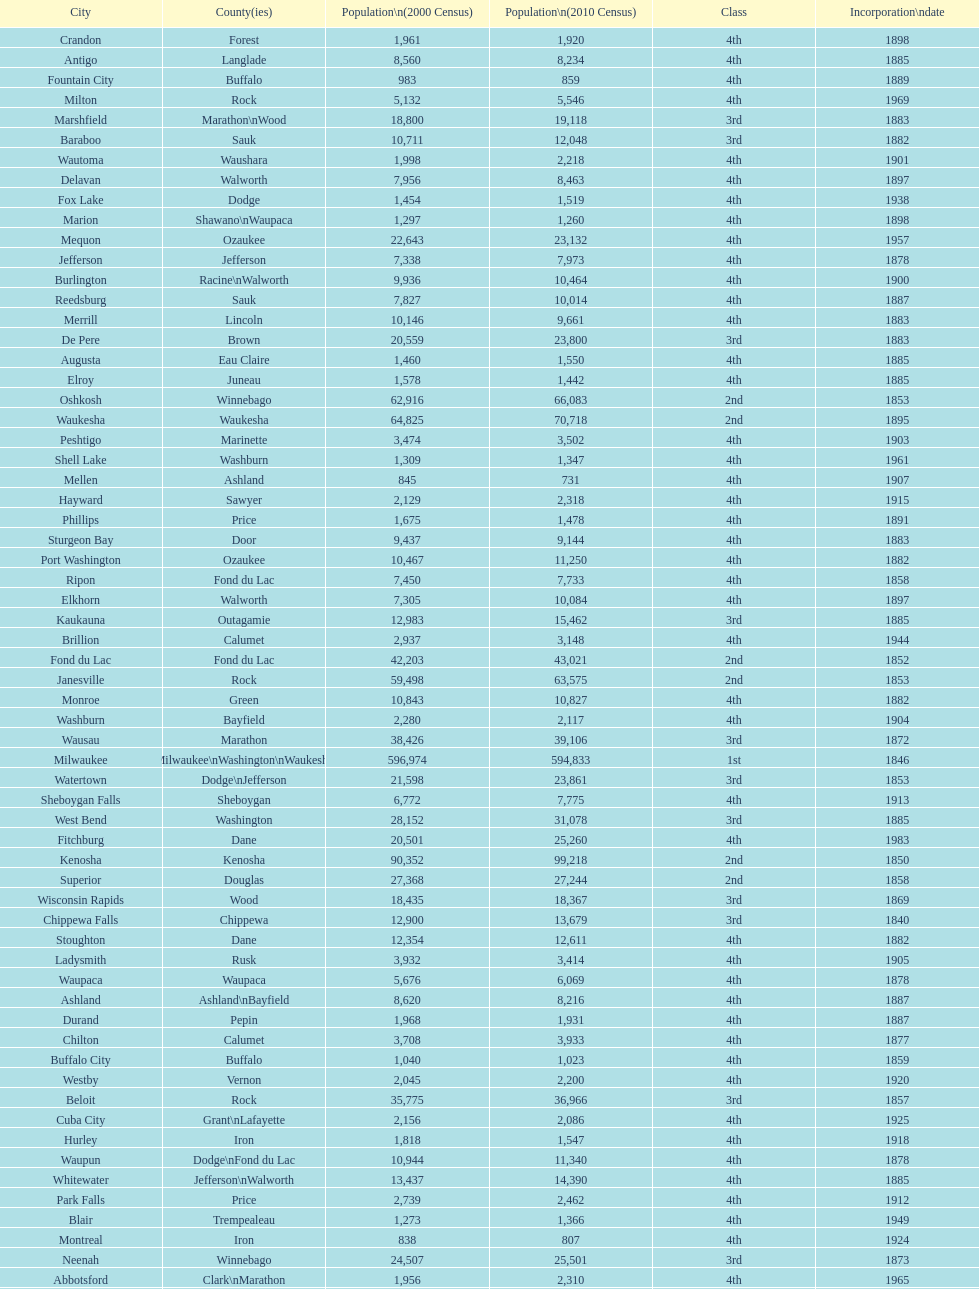Which city has the most population in the 2010 census? Milwaukee. Help me parse the entirety of this table. {'header': ['City', 'County(ies)', 'Population\\n(2000 Census)', 'Population\\n(2010 Census)', 'Class', 'Incorporation\\ndate'], 'rows': [['Crandon', 'Forest', '1,961', '1,920', '4th', '1898'], ['Antigo', 'Langlade', '8,560', '8,234', '4th', '1885'], ['Fountain City', 'Buffalo', '983', '859', '4th', '1889'], ['Milton', 'Rock', '5,132', '5,546', '4th', '1969'], ['Marshfield', 'Marathon\\nWood', '18,800', '19,118', '3rd', '1883'], ['Baraboo', 'Sauk', '10,711', '12,048', '3rd', '1882'], ['Wautoma', 'Waushara', '1,998', '2,218', '4th', '1901'], ['Delavan', 'Walworth', '7,956', '8,463', '4th', '1897'], ['Fox Lake', 'Dodge', '1,454', '1,519', '4th', '1938'], ['Marion', 'Shawano\\nWaupaca', '1,297', '1,260', '4th', '1898'], ['Mequon', 'Ozaukee', '22,643', '23,132', '4th', '1957'], ['Jefferson', 'Jefferson', '7,338', '7,973', '4th', '1878'], ['Burlington', 'Racine\\nWalworth', '9,936', '10,464', '4th', '1900'], ['Reedsburg', 'Sauk', '7,827', '10,014', '4th', '1887'], ['Merrill', 'Lincoln', '10,146', '9,661', '4th', '1883'], ['De Pere', 'Brown', '20,559', '23,800', '3rd', '1883'], ['Augusta', 'Eau Claire', '1,460', '1,550', '4th', '1885'], ['Elroy', 'Juneau', '1,578', '1,442', '4th', '1885'], ['Oshkosh', 'Winnebago', '62,916', '66,083', '2nd', '1853'], ['Waukesha', 'Waukesha', '64,825', '70,718', '2nd', '1895'], ['Peshtigo', 'Marinette', '3,474', '3,502', '4th', '1903'], ['Shell Lake', 'Washburn', '1,309', '1,347', '4th', '1961'], ['Mellen', 'Ashland', '845', '731', '4th', '1907'], ['Hayward', 'Sawyer', '2,129', '2,318', '4th', '1915'], ['Phillips', 'Price', '1,675', '1,478', '4th', '1891'], ['Sturgeon Bay', 'Door', '9,437', '9,144', '4th', '1883'], ['Port Washington', 'Ozaukee', '10,467', '11,250', '4th', '1882'], ['Ripon', 'Fond du Lac', '7,450', '7,733', '4th', '1858'], ['Elkhorn', 'Walworth', '7,305', '10,084', '4th', '1897'], ['Kaukauna', 'Outagamie', '12,983', '15,462', '3rd', '1885'], ['Brillion', 'Calumet', '2,937', '3,148', '4th', '1944'], ['Fond du Lac', 'Fond du Lac', '42,203', '43,021', '2nd', '1852'], ['Janesville', 'Rock', '59,498', '63,575', '2nd', '1853'], ['Monroe', 'Green', '10,843', '10,827', '4th', '1882'], ['Washburn', 'Bayfield', '2,280', '2,117', '4th', '1904'], ['Wausau', 'Marathon', '38,426', '39,106', '3rd', '1872'], ['Milwaukee', 'Milwaukee\\nWashington\\nWaukesha', '596,974', '594,833', '1st', '1846'], ['Watertown', 'Dodge\\nJefferson', '21,598', '23,861', '3rd', '1853'], ['Sheboygan Falls', 'Sheboygan', '6,772', '7,775', '4th', '1913'], ['West Bend', 'Washington', '28,152', '31,078', '3rd', '1885'], ['Fitchburg', 'Dane', '20,501', '25,260', '4th', '1983'], ['Kenosha', 'Kenosha', '90,352', '99,218', '2nd', '1850'], ['Superior', 'Douglas', '27,368', '27,244', '2nd', '1858'], ['Wisconsin Rapids', 'Wood', '18,435', '18,367', '3rd', '1869'], ['Chippewa Falls', 'Chippewa', '12,900', '13,679', '3rd', '1840'], ['Stoughton', 'Dane', '12,354', '12,611', '4th', '1882'], ['Ladysmith', 'Rusk', '3,932', '3,414', '4th', '1905'], ['Waupaca', 'Waupaca', '5,676', '6,069', '4th', '1878'], ['Ashland', 'Ashland\\nBayfield', '8,620', '8,216', '4th', '1887'], ['Durand', 'Pepin', '1,968', '1,931', '4th', '1887'], ['Chilton', 'Calumet', '3,708', '3,933', '4th', '1877'], ['Buffalo City', 'Buffalo', '1,040', '1,023', '4th', '1859'], ['Westby', 'Vernon', '2,045', '2,200', '4th', '1920'], ['Beloit', 'Rock', '35,775', '36,966', '3rd', '1857'], ['Cuba City', 'Grant\\nLafayette', '2,156', '2,086', '4th', '1925'], ['Hurley', 'Iron', '1,818', '1,547', '4th', '1918'], ['Waupun', 'Dodge\\nFond du Lac', '10,944', '11,340', '4th', '1878'], ['Whitewater', 'Jefferson\\nWalworth', '13,437', '14,390', '4th', '1885'], ['Park Falls', 'Price', '2,739', '2,462', '4th', '1912'], ['Blair', 'Trempealeau', '1,273', '1,366', '4th', '1949'], ['Montreal', 'Iron', '838', '807', '4th', '1924'], ['Neenah', 'Winnebago', '24,507', '25,501', '3rd', '1873'], ['Abbotsford', 'Clark\\nMarathon', '1,956', '2,310', '4th', '1965'], ['Juneau', 'Dodge', '2,485', '2,814', '4th', '1887'], ['Chetek', 'Barron', '2,180', '2,221', '4th', '1891'], ['Barron', 'Barron', '3,248', '3,423', '4th', '1887'], ['Mayville', 'Dodge', '4,902', '5,154', '4th', '1885'], ['Seymour', 'Outagamie', '3,335', '3,451', '4th', '1879'], ['Portage', 'Columbia', '9,728', '10,324', '4th', '1854'], ['Schofield', 'Marathon', '2,117', '2,169', '4th', '1951'], ['Hillsboro', 'Vernon', '1,302', '1,417', '4th', '1885'], ['Sheboygan', 'Sheboygan', '50,792', '49,288', '2nd', '1853'], ['Montello', 'Marquette', '1,397', '1,495', '4th', '1938'], ['Hudson', 'St. Croix', '8,775', '12,719', '4th', '1858'], ['Colby', 'Clark\\nMarathon', '1,616', '1,852', '4th', '1891'], ['Tomahawk', 'Lincoln', '3,770', '3,397', '4th', '1891'], ['Eau Claire', 'Chippewa\\nEau Claire', '61,704', '65,883', '2nd', '1872'], ['Clintonville', 'Waupaca', '4,736', '4,559', '4th', '1887'], ['Greenfield', 'Milwaukee', '35,476', '36,720', '3rd', '1957'], ['Greenwood', 'Clark', '1,079', '1,026', '4th', '1891'], ['Beaver Dam', 'Dodge', '15,169', '16,243', '4th', '1856'], ['Tomah', 'Monroe', '8,419', '9,093', '4th', '1883'], ['Viroqua', 'Vernon', '4,335', '5,079', '4th', '1885'], ['Nekoosa', 'Wood', '2,590', '2,580', '4th', '1926'], ['Galesville', 'Trempealeau', '1,427', '1,481', '4th', '1942'], ['Franklin', 'Milwaukee', '29,494', '35,451', '3rd', '1956'], ['Shullsburg', 'Lafayette', '1,246', '1,226', '4th', '1889'], ['Green Lake', 'Green Lake', '1,100', '960', '4th', '1962'], ['Bloomer', 'Chippewa', '3,347', '3,539', '4th', '1920'], ['Rhinelander', 'Oneida', '7,735', '7,798', '4th', '1894'], ['Muskego', 'Waukesha', '21,397', '24,135', '3rd', '1964'], ['Brodhead', 'Green\\nRock', '3,180', '3,293', '4th', '1891'], ['New Holstein', 'Calumet', '3,301', '3,236', '4th', '1889'], ['Kiel', 'Calumet\\nManitowoc', '3,450', '3,738', '4th', '1920'], ['New London', 'Outagamie\\nWaupaca', '7,085', '7,295', '4th', '1877'], ['Berlin', 'Green Lake\\nWaushara', '5,305', '5,524', '4th', '1857'], ['Glendale', 'Milwaukee', '13,367', '12,872', '3rd', '1950'], ['Cudahy', 'Milwaukee', '18,429', '18,267', '3rd', '1906'], ['Racine', 'Racine', '81,855', '78,860', '2nd', '1848'], ['Monona', 'Dane', '8,018', '7,533', '4th', '1969'], ['Lake Geneva', 'Walworth', '7,148', '7,651', '4th', '1883'], ['Madison', 'Dane', '208,054', '233,209', '2nd', '1856'], ['St. Francis', 'Milwaukee', '8,662', '9,365', '4th', '1951'], ['West Allis', 'Milwaukee', '61,254', '60,411', '2nd', '1906'], ['Niagara', 'Marinette', '1,880', '1,624', '4th', '1992'], ['Eagle River', 'Vilas', '1,443', '1,398', '4th', '1937'], ['Owen', 'Clark', '936', '940', '4th', '1925'], ['Osseo', 'Trempealeau', '1,669', '1,701', '4th', '1941'], ['South Milwaukee', 'Milwaukee', '21,256', '21,156', '4th', '1897'], ['Rice Lake', 'Barron', '8,312', '8,438', '4th', '1887'], ['Stevens Point', 'Portage', '24,551', '26,717', '3rd', '1858'], ['Horicon', 'Dodge', '3,775', '3,655', '4th', '1897'], ['Stanley', 'Chippewa\\nClark', '1,898', '3,608', '4th', '1898'], ['La Crosse', 'La Crosse', '51,818', '51,320', '2nd', '1856'], ['Oconto', 'Oconto', '4,708', '4,513', '4th', '1869'], ['Richland Center', 'Richland', '5,114', '5,184', '4th', '1887'], ['Arcadia', 'Trempealeau', '2,402', '2,925', '4th', '1925'], ['Appleton', 'Calumet\\nOutagamie\\nWinnebago', '70,087', '72,623', '2nd', '1857'], ['Mosinee', 'Marathon', '4,063', '3,988', '4th', '1931'], ['Gillett', 'Oconto', '1,262', '1,386', '4th', '1944'], ['Edgerton', 'Dane\\nRock', '4,898', '5,461', '4th', '1883'], ['Delafield', 'Waukesha', '6,472', '7,085', '4th', '1959'], ['Kewaunee', 'Kewaunee', '2,806', '2,952', '4th', '1883'], ['Prairie du Chien', 'Crawford', '6,018', '5,911', '4th', '1872'], ['Weyauwega', 'Waupaca', '1,806', '1,900', '4th', '1939'], ['Oconomowoc', 'Waukesha', '12,382', '15,712', '3rd', '1875'], ['New Lisbon', 'Juneau', '1,436', '2,554', '4th', '1889'], ['Lancaster', 'Grant', '4,070', '3,868', '4th', '1878'], ['Hartford', 'Dodge\\nWashington', '10,905', '14,223', '3rd', '1883'], ['Middleton', 'Dane', '15,770', '17,442', '3rd', '1963'], ['Platteville', 'Grant', '9,989', '11,224', '4th', '1876'], ['Shawano', 'Shawano', '8,298', '9,305', '4th', '1874'], ['Wauwatosa', 'Milwaukee', '47,271', '46,396', '2nd', '1897'], ['New Berlin', 'Waukesha', '38,220', '39,584', '3rd', '1959'], ['Plymouth', 'Sheboygan', '7,781', '8,445', '4th', '1877'], ['Dodgeville', 'Iowa', '4,220', '4,698', '4th', '1889'], ['Independence', 'Trempealeau', '1,244', '1,336', '4th', '1942'], ['Lake Mills', 'Jefferson', '4,843', '5,708', '4th', '1905'], ['Evansville', 'Rock', '4,039', '5,012', '4th', '1896'], ['Thorp', 'Clark', '1,536', '1,621', '4th', '1948'], ['Manitowoc', 'Manitowoc', '34,053', '33,736', '3rd', '1870'], ['Fennimore', 'Grant', '2,387', '2,497', '4th', '1919'], ['Oconto Falls', 'Oconto', '2,843', '2,891', '4th', '1919'], ['Princeton', 'Green Lake', '1,504', '1,214', '4th', '1920'], ['Cornell', 'Chippewa', '1,466', '1,467', '4th', '1956'], ['Algoma', 'Kewaunee', '3,357', '3,167', '4th', '1879'], ['Verona', 'Dane', '7,052', '10,619', '4th', '1977'], ['Loyal', 'Clark', '1,308', '1,261', '4th', '1948'], ['Neillsville', 'Clark', '2,731', '2,463', '4th', '1882'], ['Lodi', 'Columbia', '2,882', '3,050', '4th', '1941'], ['Glenwood City', 'St. Croix', '1,183', '1,242', '4th', '1895'], ['Black River Falls', 'Jackson', '3,618', '3,622', '4th', '1883'], ['Sparta', 'Monroe', '8,648', '9,522', '4th', '1883'], ['New Richmond', 'St. Croix', '6,310', '8,375', '4th', '1885'], ['Adams', 'Adams', '1,831', '1,967', '4th', '1926'], ['Bayfield', 'Bayfield', '611', '487', '4th', '1913'], ['Cedarburg', 'Ozaukee', '11,102', '11,412', '3rd', '1885'], ['Brookfield', 'Waukesha', '38,649', '37,920', '2nd', '1954'], ['Prescott', 'Pierce', '3,764', '4,258', '4th', '1857'], ['Waterloo', 'Jefferson', '3,259', '3,333', '4th', '1962'], ['Green Bay', 'Brown', '102,767', '104,057', '2nd', '1854'], ['Columbus', 'Columbia\\nDodge', '4,479', '4,991', '4th', '1874'], ['Oak Creek', 'Milwaukee', '28,456', '34,451', '3rd', '1955'], ['Mondovi', 'Buffalo', '2,634', '2,777', '4th', '1889'], ['Two Rivers', 'Manitowoc', '12,639', '11,712', '3rd', '1878'], ['Boscobel', 'Grant', '3,047', '3,231', '4th', '1873'], ['Darlington', 'Lafayette', '2,418', '2,451', '4th', '1877'], ['Spooner', 'Washburn', '2,653', '2,682', '4th', '1909'], ['Cumberland', 'Barron', '2,280', '2,170', '4th', '1885'], ['Alma', 'Buffalo', '942', '781', '4th', '1885'], ['Sun Prairie', 'Dane', '20,369', '29,364', '3rd', '1958'], ['Onalaska', 'La Crosse', '14,839', '17,736', '4th', '1887'], ['Markesan', 'Green Lake', '1,396', '1,476', '4th', '1959'], ['Menasha', 'Calumet\\nWinnebago', '16,331', '17,353', '3rd', '1874'], ['Omro', 'Winnebago', '3,177', '3,517', '4th', '1944'], ['St. Croix Falls', 'Polk', '2,033', '2,133', '4th', '1958'], ['Pittsville', 'Wood', '866', '874', '4th', '1887'], ['Pewaukee', 'Waukesha', '11,783', '13,195', '3rd', '1999'], ['Whitehall', 'Trempealeau', '1,651', '1,558', '4th', '1941'], ['Altoona', 'Eau Claire', '6,698', '6,706', '4th', '1887'], ['Mauston', 'Juneau', '3,740', '4,423', '4th', '1883'], ['Manawa', 'Waupaca', '1,330', '1,371', '4th', '1954'], ['Fort Atkinson', 'Jefferson', '11,621', '12,368', '4th', '1878'], ['Menomonie', 'Dunn', '14,937', '16,264', '4th', '1882'], ['Amery', 'Polk', '2,845', '2,902', '4th', '1919'], ['Wisconsin Dells', 'Adams\\nColumbia\\nJuneau\\nSauk', '2,418', '2,678', '4th', '1925'], ['Mineral Point', 'Iowa', '2,617', '2,487', '4th', '1857'], ['Medford', 'Taylor', '4,350', '4,326', '4th', '1889'], ['Marinette', 'Marinette', '11,749', '10,968', '3rd', '1887'], ['River Falls', 'Pierce\\nSt. Croix', '12,560', '15,000', '3rd', '1875']]} 